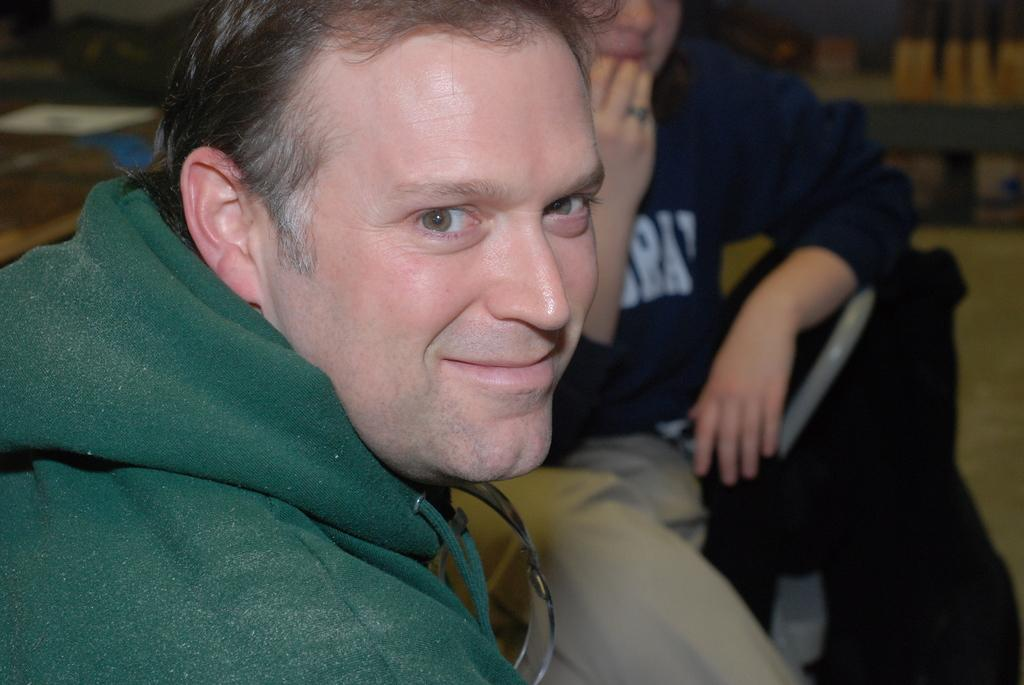What are the people in the image doing? The people in the image are sitting on chairs. Can you describe the clothing of one of the individuals in the image? Yes, a man is wearing a green hoodie in the image. What type of loaf is the man holding in the image? There is no loaf present in the image; the man is wearing a green hoodie while sitting on a chair. 